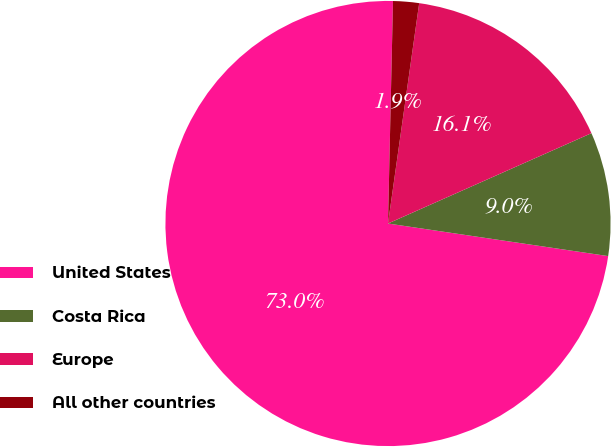Convert chart to OTSL. <chart><loc_0><loc_0><loc_500><loc_500><pie_chart><fcel>United States<fcel>Costa Rica<fcel>Europe<fcel>All other countries<nl><fcel>73.02%<fcel>8.99%<fcel>16.11%<fcel>1.88%<nl></chart> 